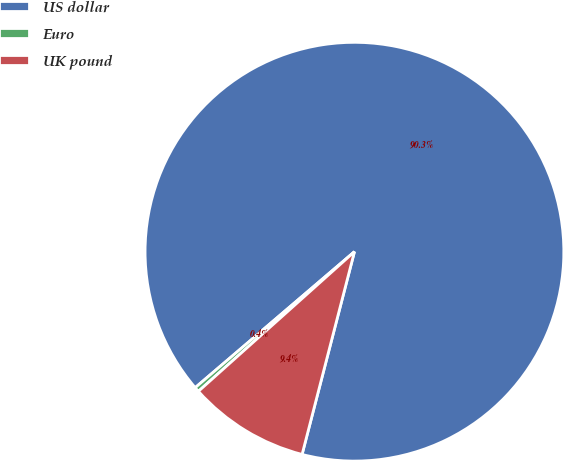Convert chart to OTSL. <chart><loc_0><loc_0><loc_500><loc_500><pie_chart><fcel>US dollar<fcel>Euro<fcel>UK pound<nl><fcel>90.27%<fcel>0.37%<fcel>9.36%<nl></chart> 